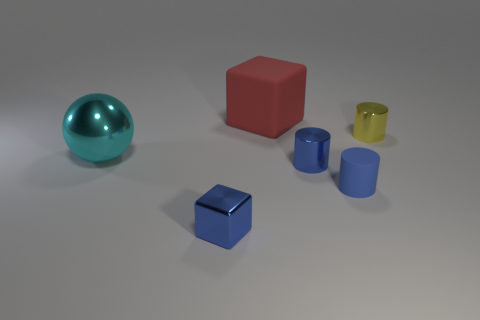How many objects are either tiny things that are to the right of the small block or small metal cylinders behind the cyan object?
Provide a succinct answer. 3. The small yellow object that is the same material as the small blue cube is what shape?
Your response must be concise. Cylinder. Are there any other things that are the same color as the sphere?
Make the answer very short. No. What material is the blue thing that is the same shape as the red thing?
Offer a terse response. Metal. What number of other things are there of the same size as the cyan ball?
Your response must be concise. 1. What is the material of the large cyan object?
Give a very brief answer. Metal. Is the number of tiny yellow shiny cylinders left of the tiny matte thing greater than the number of small blue matte objects?
Offer a very short reply. No. Is there a red rubber thing?
Provide a succinct answer. Yes. How many other things are there of the same shape as the big rubber thing?
Make the answer very short. 1. There is a rubber thing right of the blue metal cylinder; does it have the same color as the block left of the large block?
Your answer should be compact. Yes. 